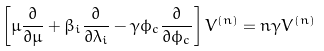<formula> <loc_0><loc_0><loc_500><loc_500>\left [ \mu \frac { \partial } { \partial \mu } + \beta _ { i } \frac { \partial } { \partial \lambda _ { i } } - \gamma \phi _ { c } \frac { \partial } { \partial \phi _ { c } } \right ] V ^ { ( n ) } = n \gamma V ^ { ( n ) }</formula> 